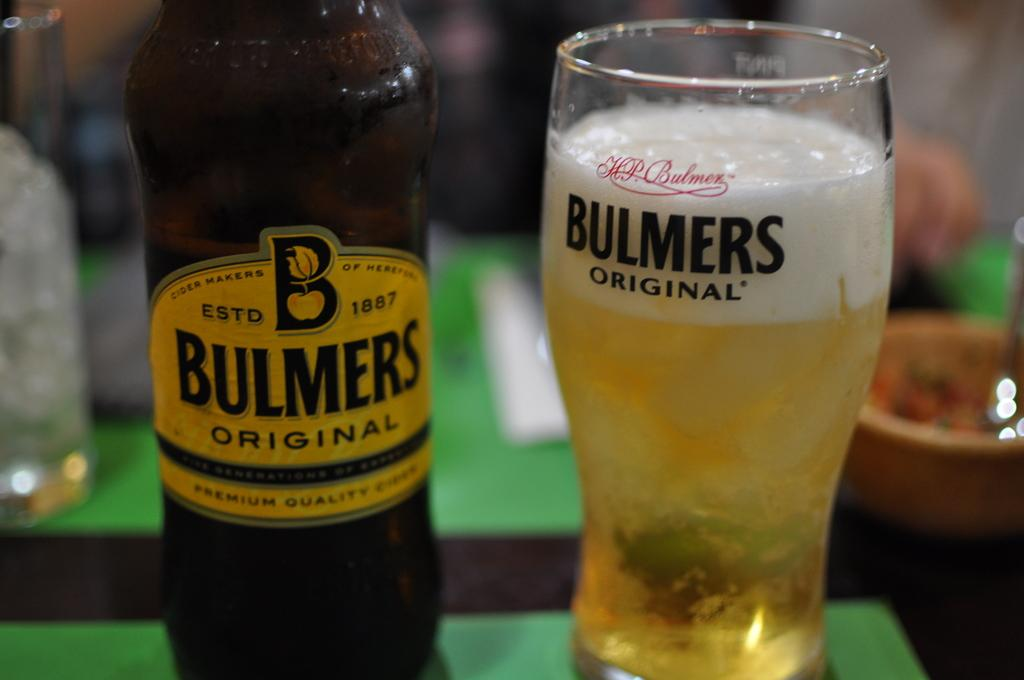Provide a one-sentence caption for the provided image. A bottle of Bulmers Original beer sits next to a glass with the same brand on it. 